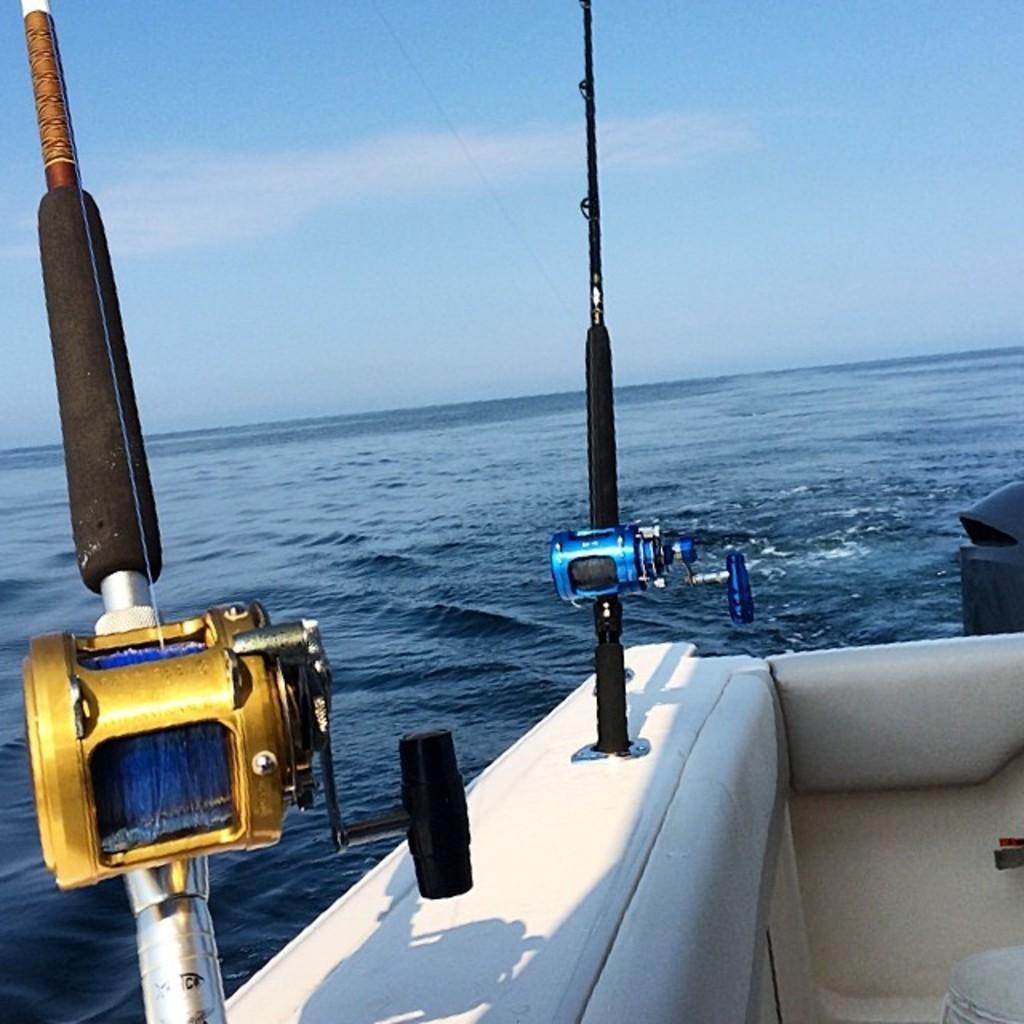How would you summarize this image in a sentence or two? In this image in the front there is a boat sailing on the water. There are objects which are black, blue and golden in colour which are on the boat. 